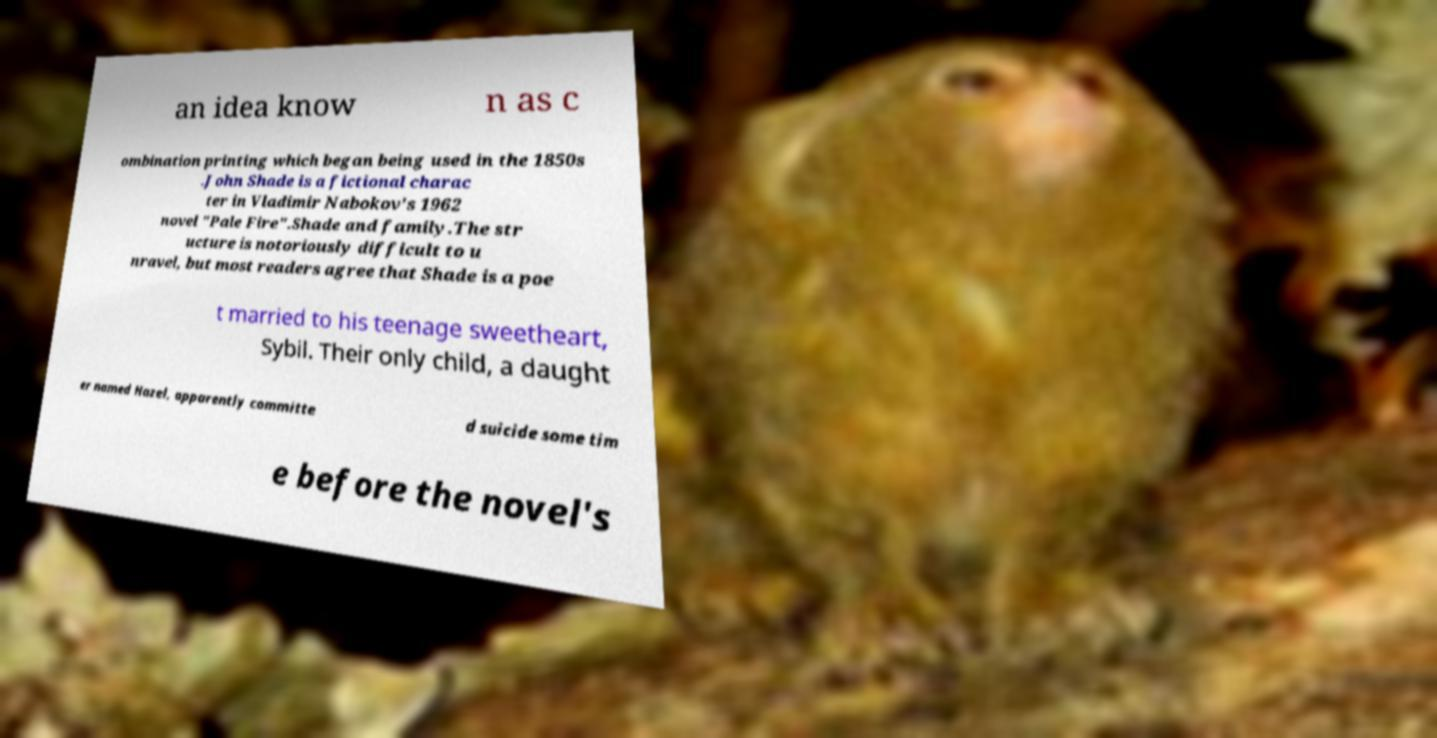What messages or text are displayed in this image? I need them in a readable, typed format. an idea know n as c ombination printing which began being used in the 1850s .John Shade is a fictional charac ter in Vladimir Nabokov's 1962 novel "Pale Fire".Shade and family.The str ucture is notoriously difficult to u nravel, but most readers agree that Shade is a poe t married to his teenage sweetheart, Sybil. Their only child, a daught er named Hazel, apparently committe d suicide some tim e before the novel's 